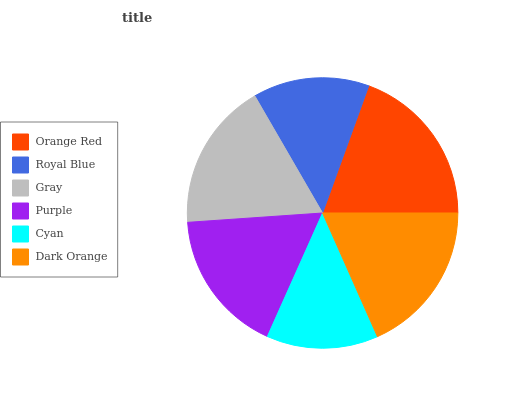Is Cyan the minimum?
Answer yes or no. Yes. Is Orange Red the maximum?
Answer yes or no. Yes. Is Royal Blue the minimum?
Answer yes or no. No. Is Royal Blue the maximum?
Answer yes or no. No. Is Orange Red greater than Royal Blue?
Answer yes or no. Yes. Is Royal Blue less than Orange Red?
Answer yes or no. Yes. Is Royal Blue greater than Orange Red?
Answer yes or no. No. Is Orange Red less than Royal Blue?
Answer yes or no. No. Is Gray the high median?
Answer yes or no. Yes. Is Purple the low median?
Answer yes or no. Yes. Is Royal Blue the high median?
Answer yes or no. No. Is Orange Red the low median?
Answer yes or no. No. 